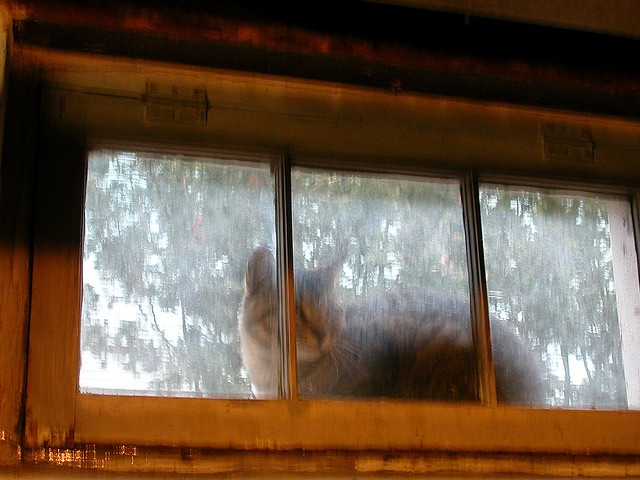Describe the objects in this image and their specific colors. I can see a cat in maroon, gray, black, and darkgray tones in this image. 